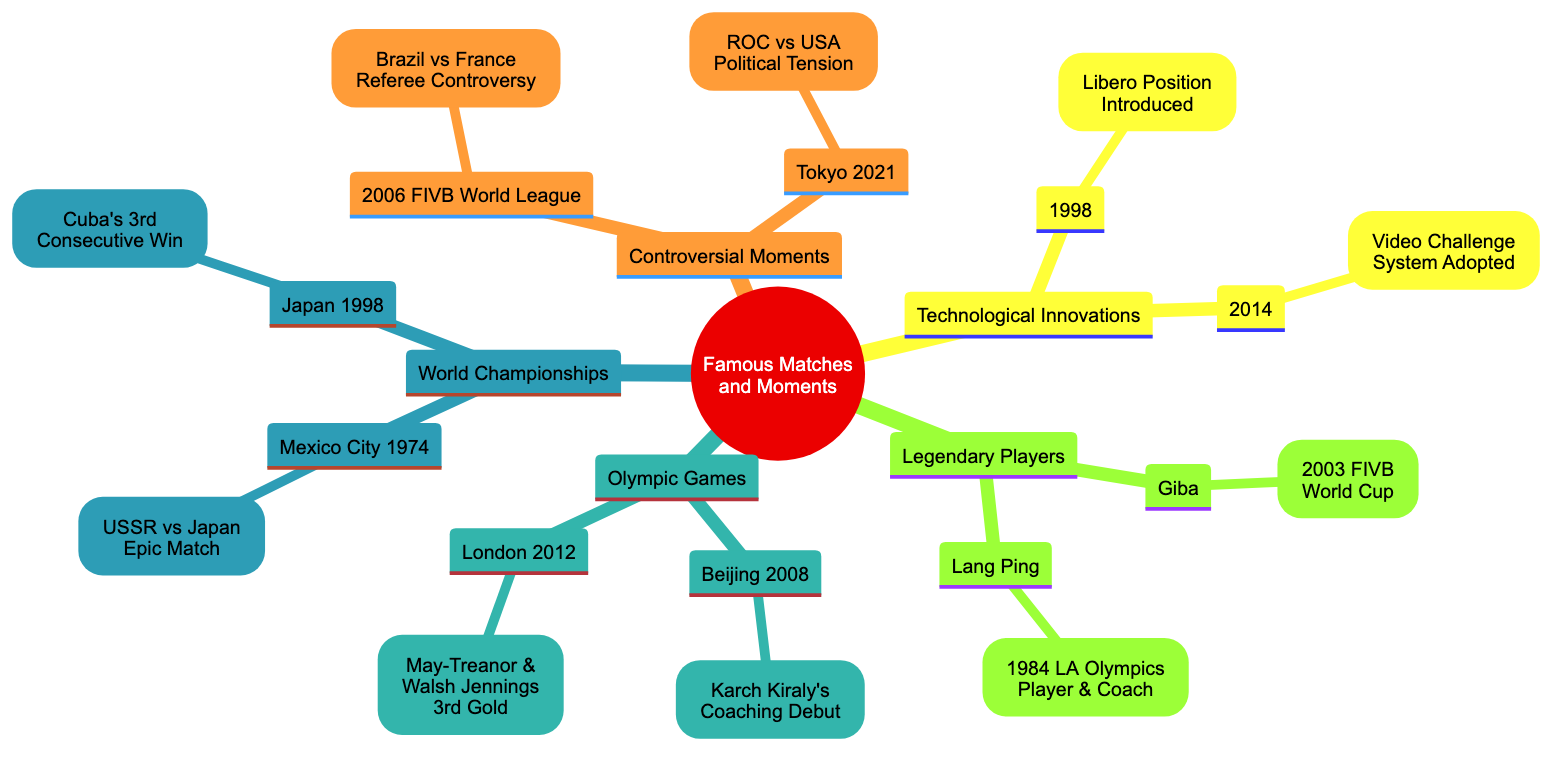What match is highlighted for the 2008 Beijing Olympics? The 2008 Beijing Olympics node specifically mentions "Karch Kiraly's Coaching Debut" as the significant match.
Answer: Karch Kiraly's Coaching Debut Who won their third consecutive gold in the 2012 London Olympics? The London 2012 Olympics node indicates "Misty May-Treanor and Kerri Walsh Jennings" as the duo who achieved this milestone.
Answer: Misty May-Treanor and Kerri Walsh Jennings What year did Cuba win their third consecutive World Championship? The 1998 Japan node under World Championships states "Cuba's Dominance" refers to their victory in that year.
Answer: 1998 How many legendary players are mentioned in the diagram? The Legendary Players section contains 2 distinct entries: Giba and Lang Ping.
Answer: 2 What position was introduced in 1998? The Technological Innovations section indicates the "Libero Position" was introduced in that year.
Answer: Libero Position Which match in 2006 was noted for referee controversy? Under Controversial Moments, the 2006 FIVB World League features "Brazil vs France" as the contentious match.
Answer: Brazil vs France Which player is associated with the 1984 LA Olympics as both player and coach? The Legendary Players section identifies "Lang Ping" as the notable figure connected with this dual role.
Answer: Lang Ping What technological advancement was adopted in 2014? The Technological Innovations node highlights the "Video Challenge System" adopted in that year.
Answer: Video Challenge System What key characteristic defined the 1974 Mexico City World Championships match? The 1974 Mexico City node states it was marked by "intense rallies and strategic plays," underlining the match's quality.
Answer: Epic Match 